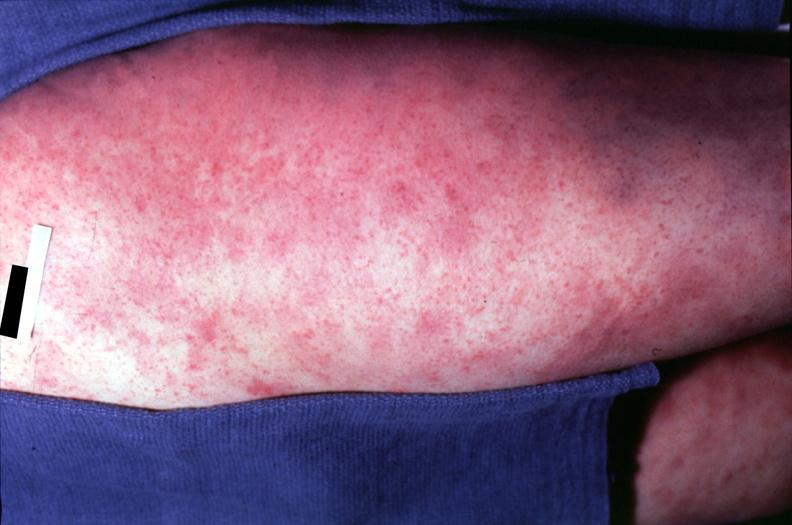does close-up show skin?
Answer the question using a single word or phrase. No 